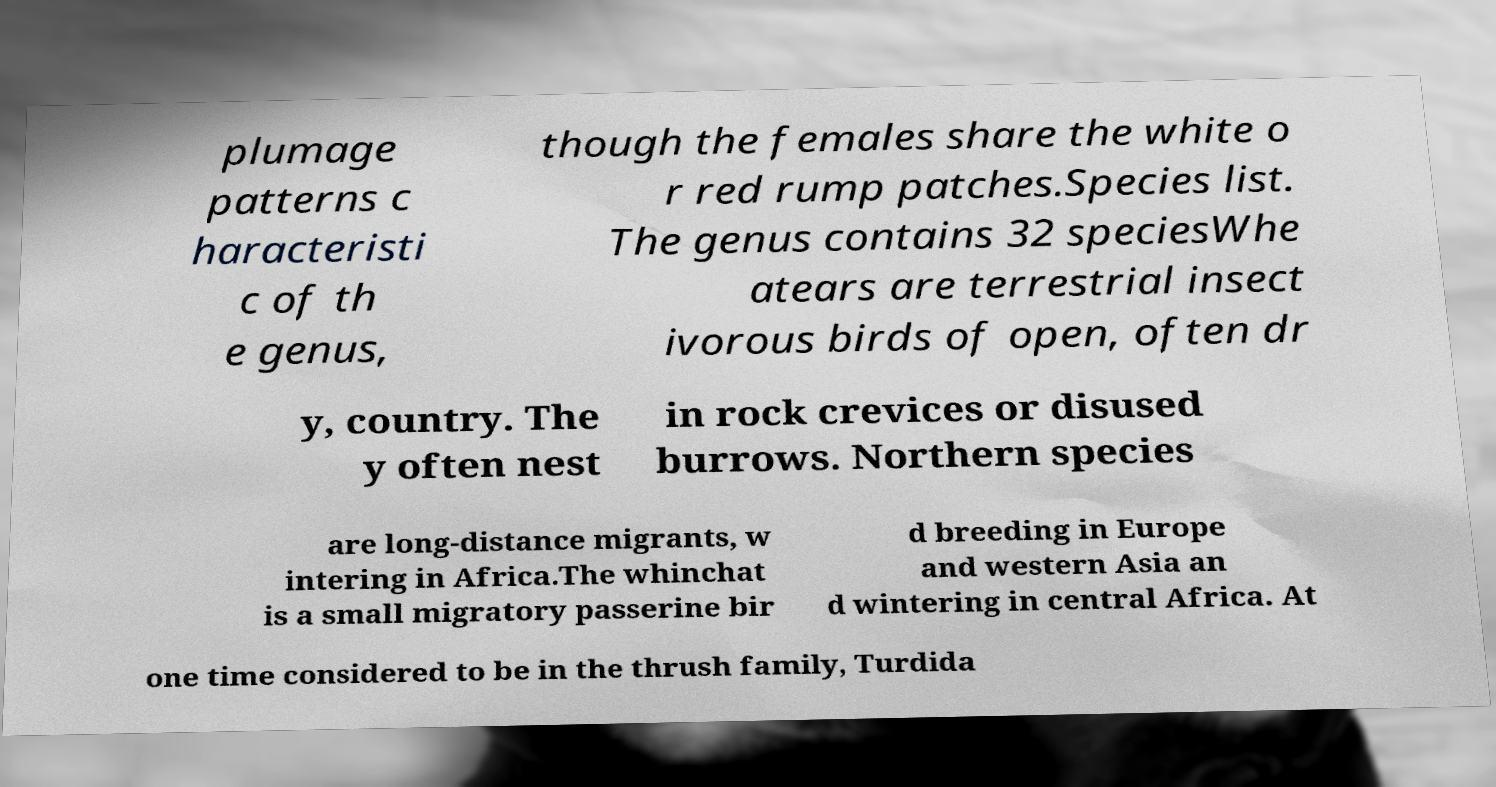Please identify and transcribe the text found in this image. plumage patterns c haracteristi c of th e genus, though the females share the white o r red rump patches.Species list. The genus contains 32 speciesWhe atears are terrestrial insect ivorous birds of open, often dr y, country. The y often nest in rock crevices or disused burrows. Northern species are long-distance migrants, w intering in Africa.The whinchat is a small migratory passerine bir d breeding in Europe and western Asia an d wintering in central Africa. At one time considered to be in the thrush family, Turdida 